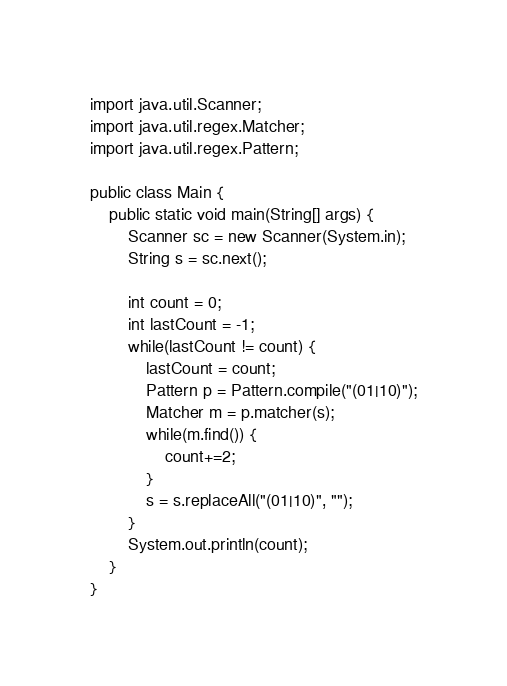Convert code to text. <code><loc_0><loc_0><loc_500><loc_500><_Java_>import java.util.Scanner;
import java.util.regex.Matcher;
import java.util.regex.Pattern;

public class Main {
	public static void main(String[] args) {
		Scanner sc = new Scanner(System.in);
		String s = sc.next();
		
		int count = 0;
		int lastCount = -1;
		while(lastCount != count) {
			lastCount = count;
			Pattern p = Pattern.compile("(01|10)");
			Matcher m = p.matcher(s);
			while(m.find()) {
				count+=2;
			}
			s = s.replaceAll("(01|10)", "");	
		}
		System.out.println(count);
	}
}</code> 